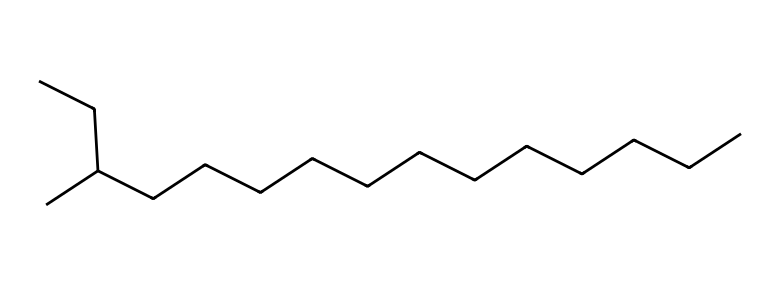What is the molecular formula of this compound? To determine the molecular formula, count the number of carbon (C) and hydrogen (H) atoms in the SMILES representation. There are 15 carbon atoms and 32 hydrogen atoms, giving the molecular formula C15H32.
Answer: C15H32 How many branches does this hydrocarbon have? The SMILES representation indicates branching by the presence of parentheses. There is one branch at the third carbon (C(C)), indicating that the hydrocarbon has one branch.
Answer: 1 What type of hydrocarbon is represented by this molecule? This molecule consists only of carbon and hydrogen atoms, and it does not contain any double or triple bonds, identifying it as an alkane.
Answer: alkane What is the number of carbon atoms in this molecule? The number of carbon atoms can be directly counted from the SMILES representation, which indicates there are 15 carbon atoms in total.
Answer: 15 What is the longest continuous carbon chain in this structure? Counting the number of continuous carbon atoms, the longest chain can be identified as containing 11 carbon atoms.
Answer: 11 What type of bonding occurs between carbon atoms in this hydrocarbon? The hydrocarbon consists solely of single bonds between carbon atoms, characterizing it as having sigma bonds (single bonds).
Answer: sigma bonds 